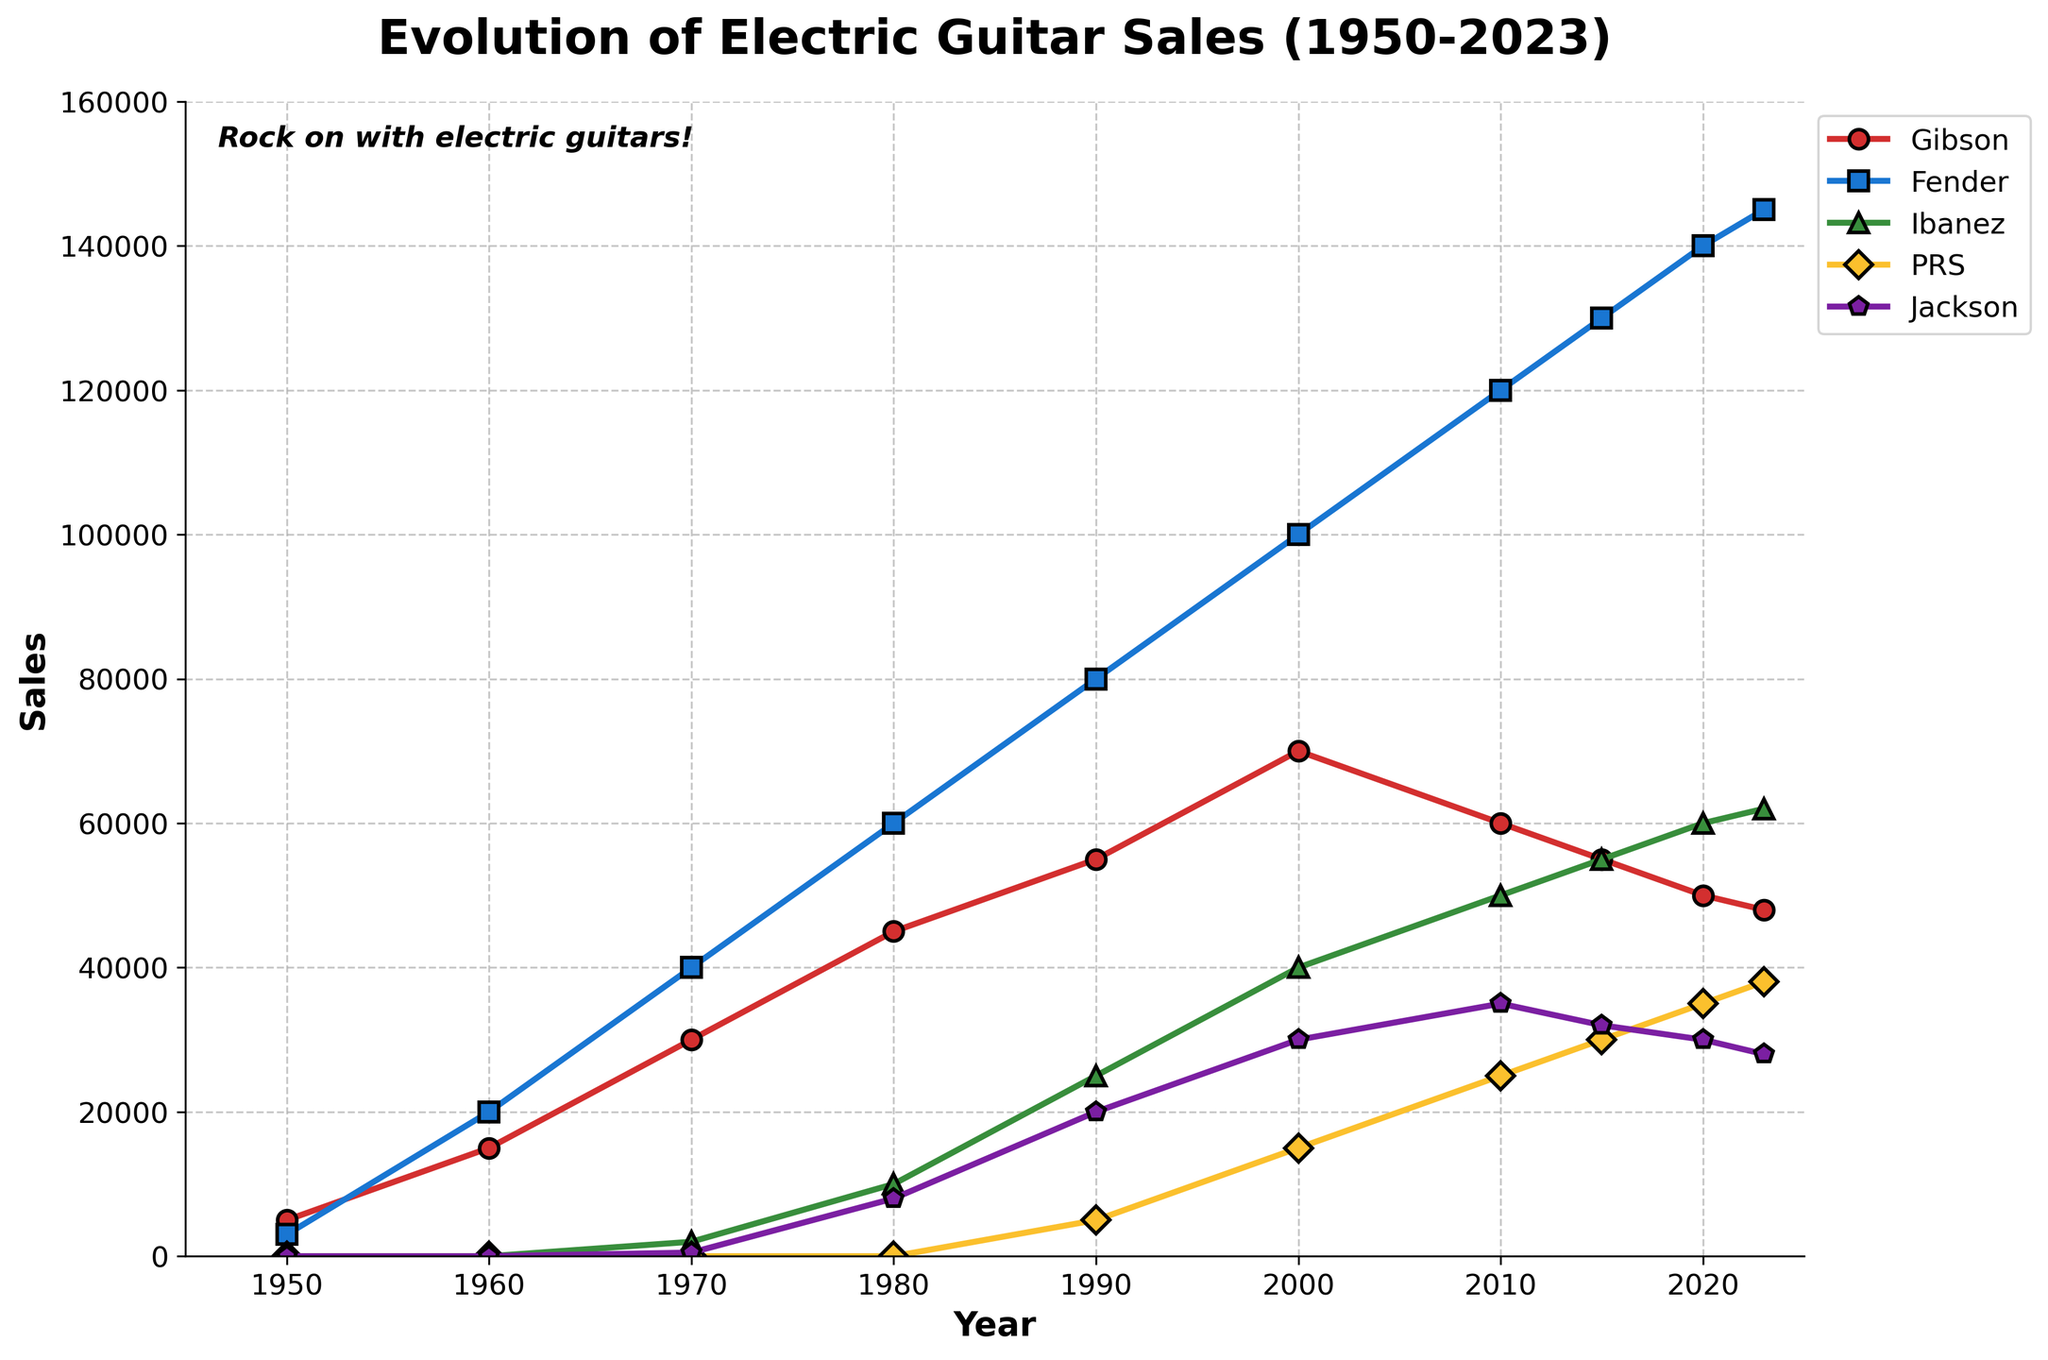What's the trend for Fender guitar sales from 1950 to 2023? The Fender guitar sales show a consistent upward trend from 1950 to 2023, starting at 3000 units in 1950 and increasing significantly over the decades to reach 145,000 units by 2023, with the steepest increases observed between 1970 and 1990 and then continuing to rise steadily.
Answer: Upward How do Gibson sales in 2023 compare to Gibson sales in 1950? Gibson sales were 5,000 units in 1950 and increased to 48,000 units by 2023. This shows a significant increase of 43,000 units over the entire period.
Answer: Increased What was the highest sales year for PRS guitars, and how many units were sold? The highest sales year for PRS guitars was 2023, with 38,000 units sold. This is evident from the PRS data line in the chart where the peak is visible at this year.
Answer: 2023, 38,000 units Compare the sales growth between Ibanez and Jackson between 1980 and 2023. Which brand had a higher growth rate? Jackson sales increased from 8,000 units in 1980 to 28,000 in 2023, giving a growth of 20,000 units. Ibanez sales increased from 10,000 units in 1980 to 62,000 in 2023, giving a growth of 52,000 units. Therefore, Ibanez had a higher growth rate during this period.
Answer: Ibanez Which year did Jackson guitar sales surpass Gibson sales, and how can you tell? Jackson guitar sales surpassed Gibson sales in 1990. This can be seen where the Jackson line crosses above the Gibson line in the graph around this year, with Jackson at 20,000 units and Gibson at 55,000 units.
Answer: 1990 What is the average sales value for Gibson guitars between 1950 and 2023? To find the average: (5000 + 15000 + 30000 + 45000 + 55000 + 70000 + 60000 + 55000 + 50000 + 48000) / 10 = 48,500 units. Calculate the total sum of sales data and divide by the number of years.
Answer: 48,500 units In terms of color, which brand has the line represented in green, and what does this color choice represent? The brand with the line represented in green is Ibanez in the chart. The green line indicates the sales trends for Ibanez guitars from 1970 onwards.
Answer: Ibanez Which brand shows a decline in sales from 2010 to 2023, and when did this decline start? Gibson shows a decline in sales from 2010 to 2023, starting from 60,000 units in 2010 to 48,000 units in 2023. The downtrend is visible by tracking the downward slope in the graph for Gibson.
Answer: Gibson If you sum up the sales of all brands in 2000, what is the total number of guitars sold? Summing up the sales in 2000: 70,000 (Gibson) + 100,000 (Fender) + 40,000 (Ibanez) + 15,000 (PRS) + 30,000 (Jackson) = 255,000 units. Calculate the total by adding the sales figures for all brands in the year 2000.
Answer: 255,000 units What were the Fender guitar sales in the year with the lowest total sales for all brands combined? The year with the lowest total sales for all brands combined is 1950, with Fender sales at 3,000 units. This is evident from adding up the sales figures for all brands across all years and identifying 1950 as the year with the minimum total.
Answer: 3,000 units 